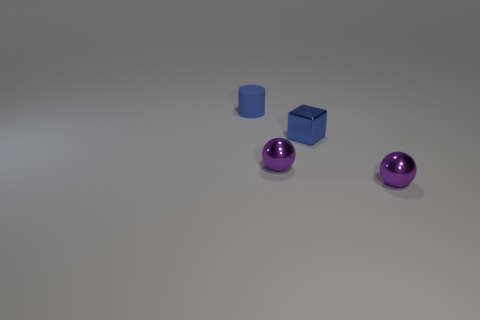Add 4 large cyan matte cubes. How many objects exist? 8 Subtract 1 balls. How many balls are left? 1 Subtract all blocks. How many objects are left? 3 Subtract all purple cylinders. Subtract all cyan spheres. How many cylinders are left? 1 Subtract all cubes. Subtract all tiny matte cylinders. How many objects are left? 2 Add 2 blue metal cubes. How many blue metal cubes are left? 3 Add 2 small blue metal cubes. How many small blue metal cubes exist? 3 Subtract 0 purple cylinders. How many objects are left? 4 